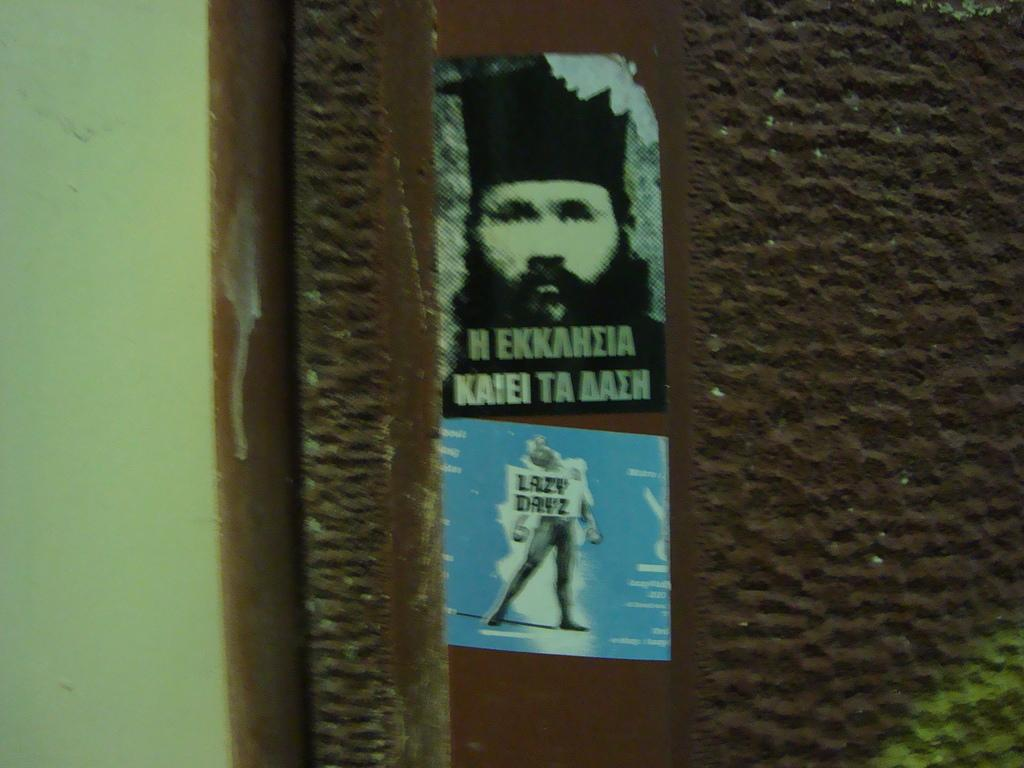What is the main structure visible in the image? There is a wall in the image. What colors are present on the wall? The wall has a green and brown color. Are there any additional structures attached to the wall? Yes, there are two posts attached to the wall. What colors are present on the posts? The posts have blue and black colors. What type of brass decoration can be seen hanging from the wall in the image? There is no brass decoration present in the image. Is there a shelf attached to the wall in the image? There is no shelf visible in the image. 